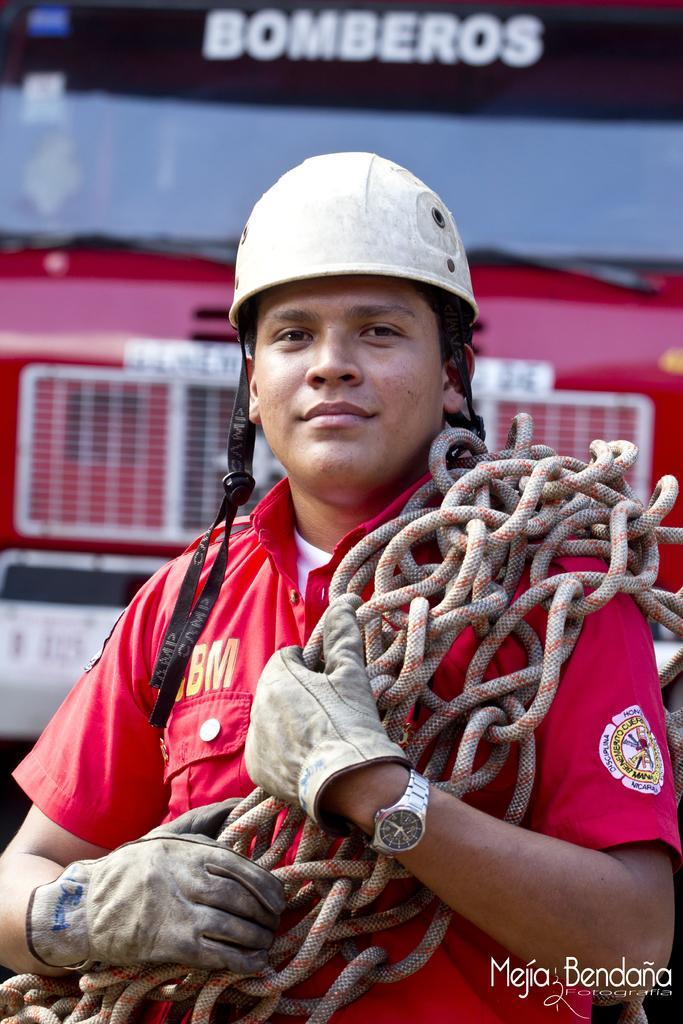Can you describe this image briefly? In this image I can see a man is standing and I can see he is holding few ropes. I can see he is wearing red colour shirt, gloves, a watch and helmet. In the background I can see a red colour vehicle and on the top and on the bottom right corner of this image I can see something is written. 